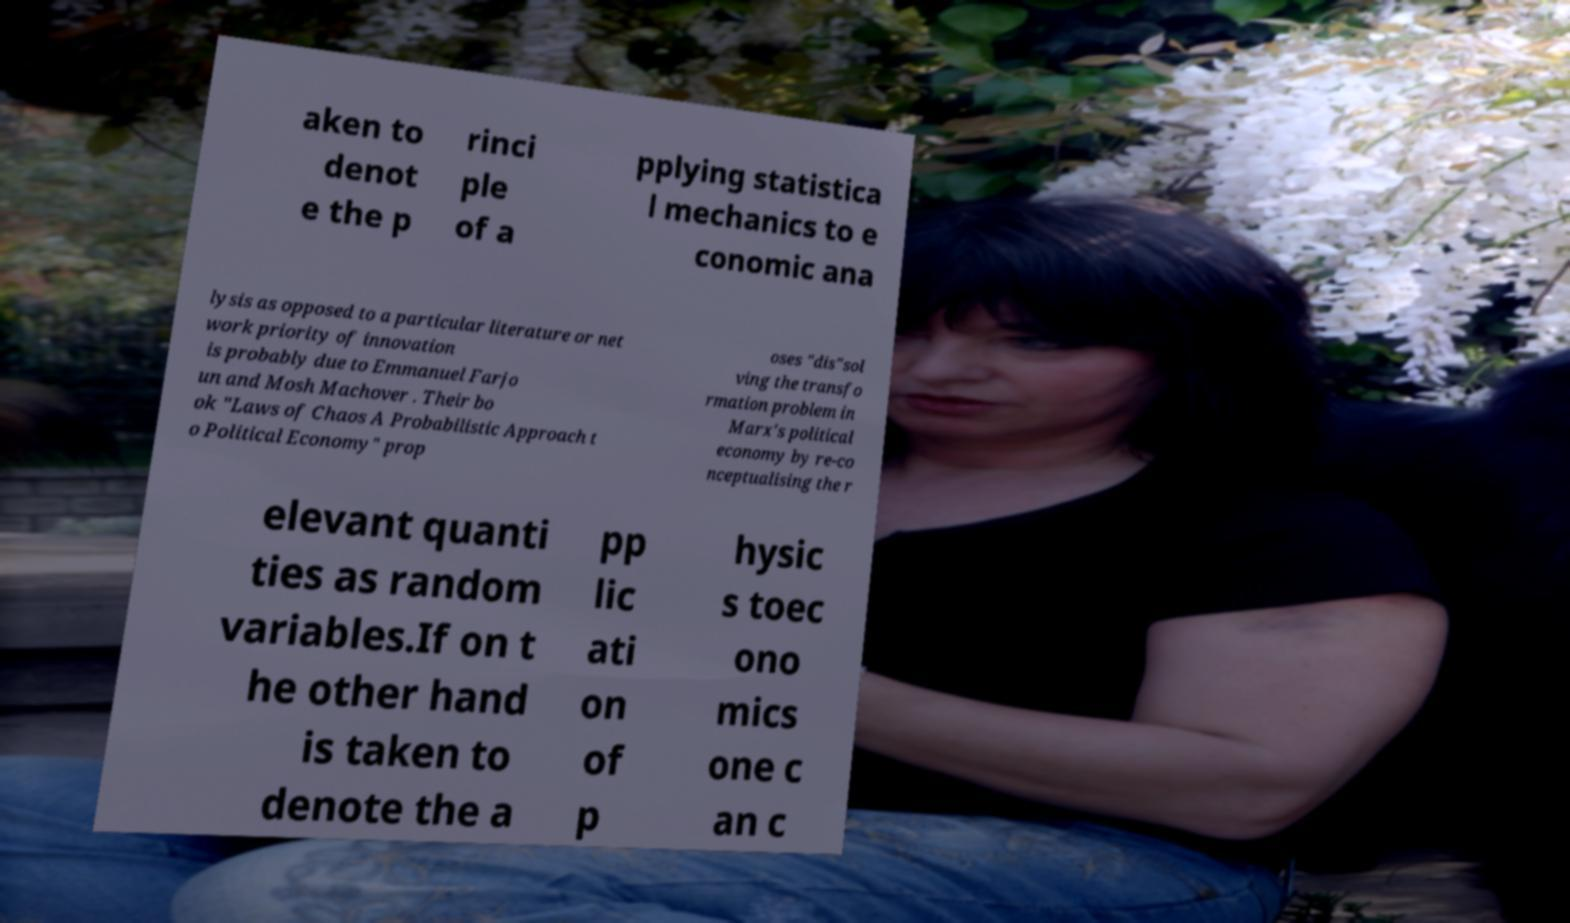Could you extract and type out the text from this image? aken to denot e the p rinci ple of a pplying statistica l mechanics to e conomic ana lysis as opposed to a particular literature or net work priority of innovation is probably due to Emmanuel Farjo un and Mosh Machover . Their bo ok "Laws of Chaos A Probabilistic Approach t o Political Economy" prop oses "dis"sol ving the transfo rmation problem in Marx's political economy by re-co nceptualising the r elevant quanti ties as random variables.If on t he other hand is taken to denote the a pp lic ati on of p hysic s toec ono mics one c an c 